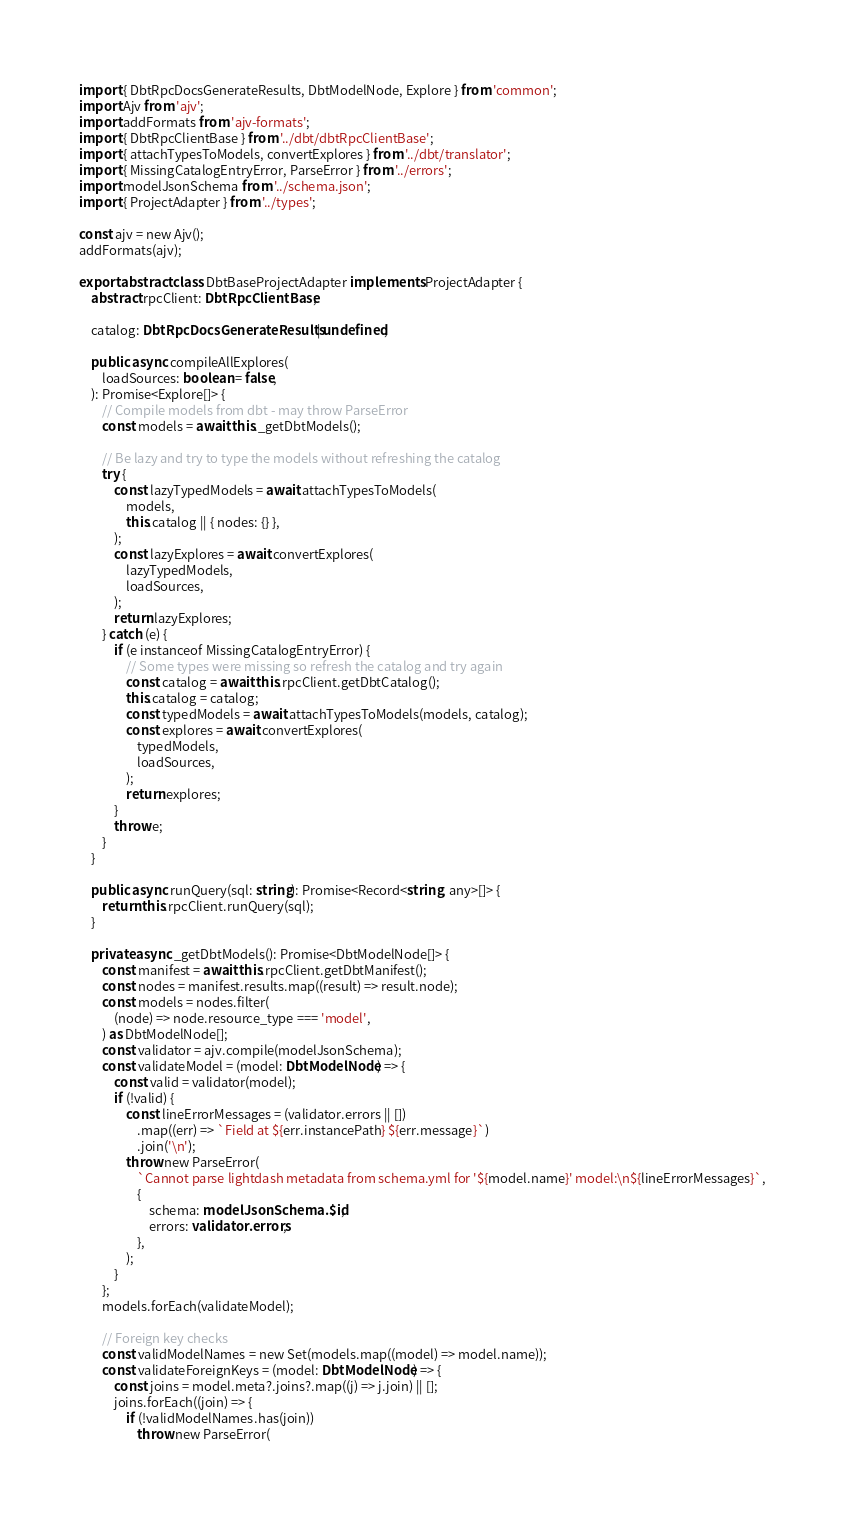Convert code to text. <code><loc_0><loc_0><loc_500><loc_500><_TypeScript_>import { DbtRpcDocsGenerateResults, DbtModelNode, Explore } from 'common';
import Ajv from 'ajv';
import addFormats from 'ajv-formats';
import { DbtRpcClientBase } from '../dbt/dbtRpcClientBase';
import { attachTypesToModels, convertExplores } from '../dbt/translator';
import { MissingCatalogEntryError, ParseError } from '../errors';
import modelJsonSchema from '../schema.json';
import { ProjectAdapter } from '../types';

const ajv = new Ajv();
addFormats(ajv);

export abstract class DbtBaseProjectAdapter implements ProjectAdapter {
    abstract rpcClient: DbtRpcClientBase;

    catalog: DbtRpcDocsGenerateResults | undefined;

    public async compileAllExplores(
        loadSources: boolean = false,
    ): Promise<Explore[]> {
        // Compile models from dbt - may throw ParseError
        const models = await this._getDbtModels();

        // Be lazy and try to type the models without refreshing the catalog
        try {
            const lazyTypedModels = await attachTypesToModels(
                models,
                this.catalog || { nodes: {} },
            );
            const lazyExplores = await convertExplores(
                lazyTypedModels,
                loadSources,
            );
            return lazyExplores;
        } catch (e) {
            if (e instanceof MissingCatalogEntryError) {
                // Some types were missing so refresh the catalog and try again
                const catalog = await this.rpcClient.getDbtCatalog();
                this.catalog = catalog;
                const typedModels = await attachTypesToModels(models, catalog);
                const explores = await convertExplores(
                    typedModels,
                    loadSources,
                );
                return explores;
            }
            throw e;
        }
    }

    public async runQuery(sql: string): Promise<Record<string, any>[]> {
        return this.rpcClient.runQuery(sql);
    }

    private async _getDbtModels(): Promise<DbtModelNode[]> {
        const manifest = await this.rpcClient.getDbtManifest();
        const nodes = manifest.results.map((result) => result.node);
        const models = nodes.filter(
            (node) => node.resource_type === 'model',
        ) as DbtModelNode[];
        const validator = ajv.compile(modelJsonSchema);
        const validateModel = (model: DbtModelNode) => {
            const valid = validator(model);
            if (!valid) {
                const lineErrorMessages = (validator.errors || [])
                    .map((err) => `Field at ${err.instancePath} ${err.message}`)
                    .join('\n');
                throw new ParseError(
                    `Cannot parse lightdash metadata from schema.yml for '${model.name}' model:\n${lineErrorMessages}`,
                    {
                        schema: modelJsonSchema.$id,
                        errors: validator.errors,
                    },
                );
            }
        };
        models.forEach(validateModel);

        // Foreign key checks
        const validModelNames = new Set(models.map((model) => model.name));
        const validateForeignKeys = (model: DbtModelNode) => {
            const joins = model.meta?.joins?.map((j) => j.join) || [];
            joins.forEach((join) => {
                if (!validModelNames.has(join))
                    throw new ParseError(</code> 